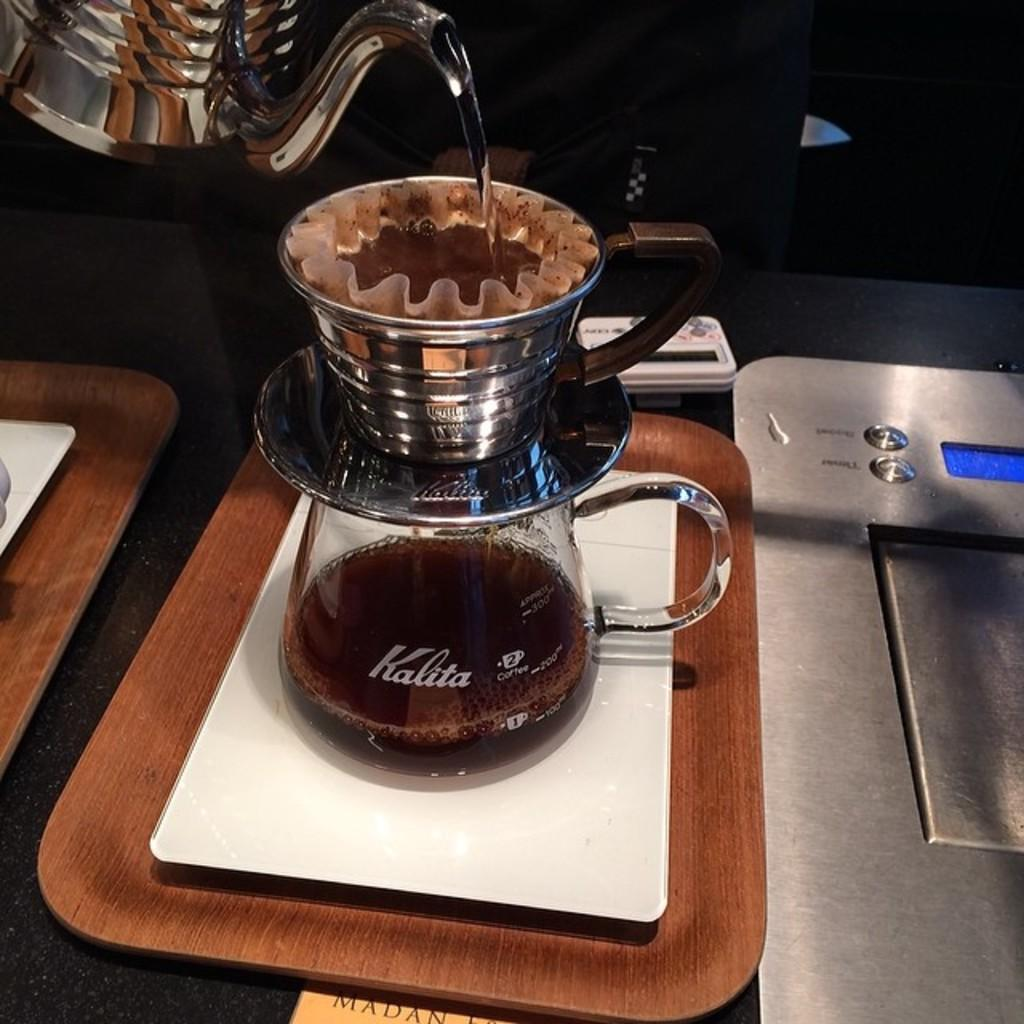<image>
Relay a brief, clear account of the picture shown. a Kalita glass that has coffee in it 